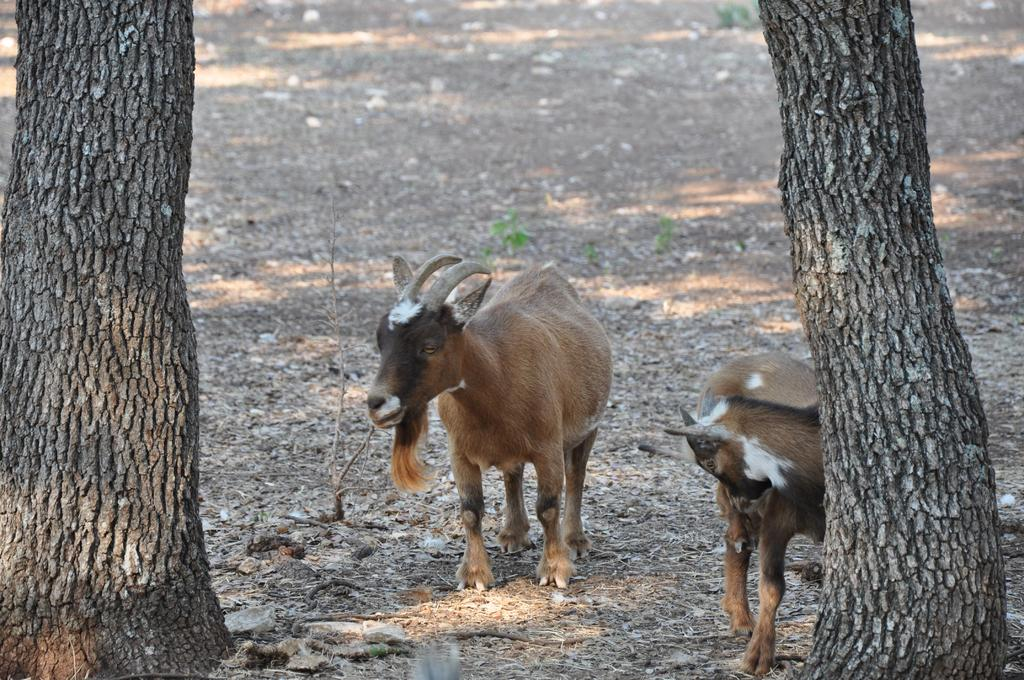How many animals are present in the image? There are two animals in the image. What else can be seen in the image besides the animals? There are two trees and plants on the surface in the image. What type of alley can be seen in the background of the image? There is no alley present in the image; it features two animals, two trees, and plants on the surface. 